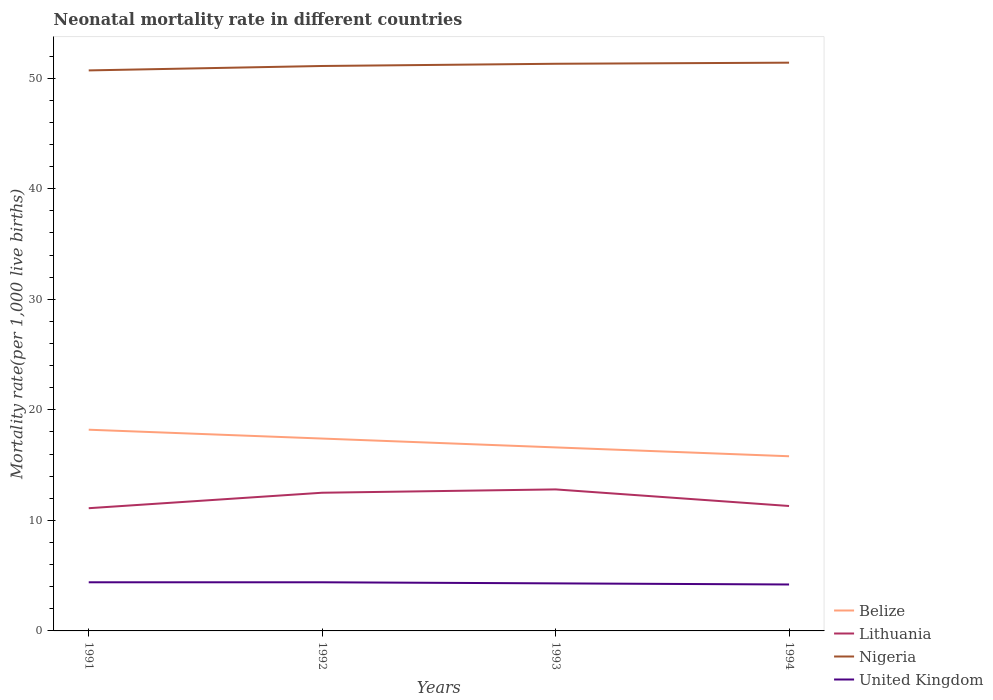How many different coloured lines are there?
Make the answer very short. 4. Across all years, what is the maximum neonatal mortality rate in Belize?
Provide a succinct answer. 15.8. What is the total neonatal mortality rate in United Kingdom in the graph?
Make the answer very short. 0.1. What is the difference between the highest and the second highest neonatal mortality rate in Nigeria?
Offer a very short reply. 0.7. Is the neonatal mortality rate in Nigeria strictly greater than the neonatal mortality rate in United Kingdom over the years?
Offer a terse response. No. How many years are there in the graph?
Offer a terse response. 4. Are the values on the major ticks of Y-axis written in scientific E-notation?
Your answer should be compact. No. Does the graph contain grids?
Make the answer very short. No. Where does the legend appear in the graph?
Your answer should be compact. Bottom right. What is the title of the graph?
Offer a terse response. Neonatal mortality rate in different countries. What is the label or title of the Y-axis?
Offer a very short reply. Mortality rate(per 1,0 live births). What is the Mortality rate(per 1,000 live births) of Belize in 1991?
Offer a terse response. 18.2. What is the Mortality rate(per 1,000 live births) of Lithuania in 1991?
Ensure brevity in your answer.  11.1. What is the Mortality rate(per 1,000 live births) in Nigeria in 1991?
Your answer should be compact. 50.7. What is the Mortality rate(per 1,000 live births) of Belize in 1992?
Provide a succinct answer. 17.4. What is the Mortality rate(per 1,000 live births) in Lithuania in 1992?
Provide a succinct answer. 12.5. What is the Mortality rate(per 1,000 live births) in Nigeria in 1992?
Keep it short and to the point. 51.1. What is the Mortality rate(per 1,000 live births) in Belize in 1993?
Offer a terse response. 16.6. What is the Mortality rate(per 1,000 live births) of Lithuania in 1993?
Ensure brevity in your answer.  12.8. What is the Mortality rate(per 1,000 live births) of Nigeria in 1993?
Give a very brief answer. 51.3. What is the Mortality rate(per 1,000 live births) of United Kingdom in 1993?
Offer a very short reply. 4.3. What is the Mortality rate(per 1,000 live births) of Lithuania in 1994?
Keep it short and to the point. 11.3. What is the Mortality rate(per 1,000 live births) in Nigeria in 1994?
Provide a short and direct response. 51.4. What is the Mortality rate(per 1,000 live births) in United Kingdom in 1994?
Ensure brevity in your answer.  4.2. Across all years, what is the maximum Mortality rate(per 1,000 live births) in Nigeria?
Ensure brevity in your answer.  51.4. Across all years, what is the maximum Mortality rate(per 1,000 live births) of United Kingdom?
Make the answer very short. 4.4. Across all years, what is the minimum Mortality rate(per 1,000 live births) of Belize?
Keep it short and to the point. 15.8. Across all years, what is the minimum Mortality rate(per 1,000 live births) in Lithuania?
Keep it short and to the point. 11.1. Across all years, what is the minimum Mortality rate(per 1,000 live births) in Nigeria?
Your answer should be compact. 50.7. What is the total Mortality rate(per 1,000 live births) in Belize in the graph?
Offer a terse response. 68. What is the total Mortality rate(per 1,000 live births) of Lithuania in the graph?
Offer a very short reply. 47.7. What is the total Mortality rate(per 1,000 live births) in Nigeria in the graph?
Offer a terse response. 204.5. What is the total Mortality rate(per 1,000 live births) of United Kingdom in the graph?
Make the answer very short. 17.3. What is the difference between the Mortality rate(per 1,000 live births) in Lithuania in 1991 and that in 1992?
Make the answer very short. -1.4. What is the difference between the Mortality rate(per 1,000 live births) in Belize in 1991 and that in 1993?
Provide a succinct answer. 1.6. What is the difference between the Mortality rate(per 1,000 live births) of Lithuania in 1991 and that in 1993?
Ensure brevity in your answer.  -1.7. What is the difference between the Mortality rate(per 1,000 live births) of Nigeria in 1991 and that in 1993?
Provide a short and direct response. -0.6. What is the difference between the Mortality rate(per 1,000 live births) of Belize in 1991 and that in 1994?
Your response must be concise. 2.4. What is the difference between the Mortality rate(per 1,000 live births) in Lithuania in 1991 and that in 1994?
Offer a terse response. -0.2. What is the difference between the Mortality rate(per 1,000 live births) of Nigeria in 1991 and that in 1994?
Your answer should be very brief. -0.7. What is the difference between the Mortality rate(per 1,000 live births) of Nigeria in 1992 and that in 1993?
Your answer should be compact. -0.2. What is the difference between the Mortality rate(per 1,000 live births) in Lithuania in 1992 and that in 1994?
Offer a very short reply. 1.2. What is the difference between the Mortality rate(per 1,000 live births) of United Kingdom in 1992 and that in 1994?
Your answer should be compact. 0.2. What is the difference between the Mortality rate(per 1,000 live births) of Nigeria in 1993 and that in 1994?
Offer a very short reply. -0.1. What is the difference between the Mortality rate(per 1,000 live births) of Belize in 1991 and the Mortality rate(per 1,000 live births) of Lithuania in 1992?
Your response must be concise. 5.7. What is the difference between the Mortality rate(per 1,000 live births) in Belize in 1991 and the Mortality rate(per 1,000 live births) in Nigeria in 1992?
Offer a terse response. -32.9. What is the difference between the Mortality rate(per 1,000 live births) of Belize in 1991 and the Mortality rate(per 1,000 live births) of United Kingdom in 1992?
Offer a terse response. 13.8. What is the difference between the Mortality rate(per 1,000 live births) of Lithuania in 1991 and the Mortality rate(per 1,000 live births) of Nigeria in 1992?
Give a very brief answer. -40. What is the difference between the Mortality rate(per 1,000 live births) in Nigeria in 1991 and the Mortality rate(per 1,000 live births) in United Kingdom in 1992?
Offer a terse response. 46.3. What is the difference between the Mortality rate(per 1,000 live births) in Belize in 1991 and the Mortality rate(per 1,000 live births) in Nigeria in 1993?
Provide a succinct answer. -33.1. What is the difference between the Mortality rate(per 1,000 live births) in Lithuania in 1991 and the Mortality rate(per 1,000 live births) in Nigeria in 1993?
Provide a succinct answer. -40.2. What is the difference between the Mortality rate(per 1,000 live births) in Nigeria in 1991 and the Mortality rate(per 1,000 live births) in United Kingdom in 1993?
Give a very brief answer. 46.4. What is the difference between the Mortality rate(per 1,000 live births) in Belize in 1991 and the Mortality rate(per 1,000 live births) in Nigeria in 1994?
Offer a very short reply. -33.2. What is the difference between the Mortality rate(per 1,000 live births) in Belize in 1991 and the Mortality rate(per 1,000 live births) in United Kingdom in 1994?
Offer a terse response. 14. What is the difference between the Mortality rate(per 1,000 live births) of Lithuania in 1991 and the Mortality rate(per 1,000 live births) of Nigeria in 1994?
Offer a terse response. -40.3. What is the difference between the Mortality rate(per 1,000 live births) of Nigeria in 1991 and the Mortality rate(per 1,000 live births) of United Kingdom in 1994?
Offer a terse response. 46.5. What is the difference between the Mortality rate(per 1,000 live births) of Belize in 1992 and the Mortality rate(per 1,000 live births) of Nigeria in 1993?
Offer a terse response. -33.9. What is the difference between the Mortality rate(per 1,000 live births) in Belize in 1992 and the Mortality rate(per 1,000 live births) in United Kingdom in 1993?
Offer a terse response. 13.1. What is the difference between the Mortality rate(per 1,000 live births) of Lithuania in 1992 and the Mortality rate(per 1,000 live births) of Nigeria in 1993?
Your response must be concise. -38.8. What is the difference between the Mortality rate(per 1,000 live births) in Lithuania in 1992 and the Mortality rate(per 1,000 live births) in United Kingdom in 1993?
Your response must be concise. 8.2. What is the difference between the Mortality rate(per 1,000 live births) of Nigeria in 1992 and the Mortality rate(per 1,000 live births) of United Kingdom in 1993?
Offer a very short reply. 46.8. What is the difference between the Mortality rate(per 1,000 live births) in Belize in 1992 and the Mortality rate(per 1,000 live births) in Lithuania in 1994?
Keep it short and to the point. 6.1. What is the difference between the Mortality rate(per 1,000 live births) of Belize in 1992 and the Mortality rate(per 1,000 live births) of Nigeria in 1994?
Your response must be concise. -34. What is the difference between the Mortality rate(per 1,000 live births) of Lithuania in 1992 and the Mortality rate(per 1,000 live births) of Nigeria in 1994?
Your answer should be compact. -38.9. What is the difference between the Mortality rate(per 1,000 live births) in Nigeria in 1992 and the Mortality rate(per 1,000 live births) in United Kingdom in 1994?
Provide a succinct answer. 46.9. What is the difference between the Mortality rate(per 1,000 live births) of Belize in 1993 and the Mortality rate(per 1,000 live births) of Nigeria in 1994?
Offer a very short reply. -34.8. What is the difference between the Mortality rate(per 1,000 live births) in Belize in 1993 and the Mortality rate(per 1,000 live births) in United Kingdom in 1994?
Provide a short and direct response. 12.4. What is the difference between the Mortality rate(per 1,000 live births) of Lithuania in 1993 and the Mortality rate(per 1,000 live births) of Nigeria in 1994?
Provide a succinct answer. -38.6. What is the difference between the Mortality rate(per 1,000 live births) of Nigeria in 1993 and the Mortality rate(per 1,000 live births) of United Kingdom in 1994?
Ensure brevity in your answer.  47.1. What is the average Mortality rate(per 1,000 live births) in Belize per year?
Provide a succinct answer. 17. What is the average Mortality rate(per 1,000 live births) of Lithuania per year?
Your answer should be very brief. 11.93. What is the average Mortality rate(per 1,000 live births) of Nigeria per year?
Keep it short and to the point. 51.12. What is the average Mortality rate(per 1,000 live births) in United Kingdom per year?
Offer a terse response. 4.33. In the year 1991, what is the difference between the Mortality rate(per 1,000 live births) of Belize and Mortality rate(per 1,000 live births) of Nigeria?
Your answer should be compact. -32.5. In the year 1991, what is the difference between the Mortality rate(per 1,000 live births) of Belize and Mortality rate(per 1,000 live births) of United Kingdom?
Provide a succinct answer. 13.8. In the year 1991, what is the difference between the Mortality rate(per 1,000 live births) of Lithuania and Mortality rate(per 1,000 live births) of Nigeria?
Offer a very short reply. -39.6. In the year 1991, what is the difference between the Mortality rate(per 1,000 live births) of Nigeria and Mortality rate(per 1,000 live births) of United Kingdom?
Give a very brief answer. 46.3. In the year 1992, what is the difference between the Mortality rate(per 1,000 live births) of Belize and Mortality rate(per 1,000 live births) of Lithuania?
Your answer should be very brief. 4.9. In the year 1992, what is the difference between the Mortality rate(per 1,000 live births) of Belize and Mortality rate(per 1,000 live births) of Nigeria?
Your response must be concise. -33.7. In the year 1992, what is the difference between the Mortality rate(per 1,000 live births) in Lithuania and Mortality rate(per 1,000 live births) in Nigeria?
Your answer should be compact. -38.6. In the year 1992, what is the difference between the Mortality rate(per 1,000 live births) of Lithuania and Mortality rate(per 1,000 live births) of United Kingdom?
Your response must be concise. 8.1. In the year 1992, what is the difference between the Mortality rate(per 1,000 live births) in Nigeria and Mortality rate(per 1,000 live births) in United Kingdom?
Make the answer very short. 46.7. In the year 1993, what is the difference between the Mortality rate(per 1,000 live births) in Belize and Mortality rate(per 1,000 live births) in Nigeria?
Keep it short and to the point. -34.7. In the year 1993, what is the difference between the Mortality rate(per 1,000 live births) of Lithuania and Mortality rate(per 1,000 live births) of Nigeria?
Ensure brevity in your answer.  -38.5. In the year 1993, what is the difference between the Mortality rate(per 1,000 live births) in Lithuania and Mortality rate(per 1,000 live births) in United Kingdom?
Give a very brief answer. 8.5. In the year 1993, what is the difference between the Mortality rate(per 1,000 live births) in Nigeria and Mortality rate(per 1,000 live births) in United Kingdom?
Your response must be concise. 47. In the year 1994, what is the difference between the Mortality rate(per 1,000 live births) in Belize and Mortality rate(per 1,000 live births) in Lithuania?
Make the answer very short. 4.5. In the year 1994, what is the difference between the Mortality rate(per 1,000 live births) of Belize and Mortality rate(per 1,000 live births) of Nigeria?
Your answer should be compact. -35.6. In the year 1994, what is the difference between the Mortality rate(per 1,000 live births) of Belize and Mortality rate(per 1,000 live births) of United Kingdom?
Your response must be concise. 11.6. In the year 1994, what is the difference between the Mortality rate(per 1,000 live births) in Lithuania and Mortality rate(per 1,000 live births) in Nigeria?
Provide a succinct answer. -40.1. In the year 1994, what is the difference between the Mortality rate(per 1,000 live births) in Lithuania and Mortality rate(per 1,000 live births) in United Kingdom?
Your answer should be very brief. 7.1. In the year 1994, what is the difference between the Mortality rate(per 1,000 live births) in Nigeria and Mortality rate(per 1,000 live births) in United Kingdom?
Give a very brief answer. 47.2. What is the ratio of the Mortality rate(per 1,000 live births) in Belize in 1991 to that in 1992?
Offer a terse response. 1.05. What is the ratio of the Mortality rate(per 1,000 live births) in Lithuania in 1991 to that in 1992?
Make the answer very short. 0.89. What is the ratio of the Mortality rate(per 1,000 live births) in Nigeria in 1991 to that in 1992?
Make the answer very short. 0.99. What is the ratio of the Mortality rate(per 1,000 live births) of United Kingdom in 1991 to that in 1992?
Your response must be concise. 1. What is the ratio of the Mortality rate(per 1,000 live births) of Belize in 1991 to that in 1993?
Provide a succinct answer. 1.1. What is the ratio of the Mortality rate(per 1,000 live births) of Lithuania in 1991 to that in 1993?
Your answer should be compact. 0.87. What is the ratio of the Mortality rate(per 1,000 live births) in Nigeria in 1991 to that in 1993?
Offer a very short reply. 0.99. What is the ratio of the Mortality rate(per 1,000 live births) in United Kingdom in 1991 to that in 1993?
Offer a terse response. 1.02. What is the ratio of the Mortality rate(per 1,000 live births) of Belize in 1991 to that in 1994?
Your response must be concise. 1.15. What is the ratio of the Mortality rate(per 1,000 live births) of Lithuania in 1991 to that in 1994?
Ensure brevity in your answer.  0.98. What is the ratio of the Mortality rate(per 1,000 live births) of Nigeria in 1991 to that in 1994?
Give a very brief answer. 0.99. What is the ratio of the Mortality rate(per 1,000 live births) of United Kingdom in 1991 to that in 1994?
Offer a terse response. 1.05. What is the ratio of the Mortality rate(per 1,000 live births) in Belize in 1992 to that in 1993?
Give a very brief answer. 1.05. What is the ratio of the Mortality rate(per 1,000 live births) in Lithuania in 1992 to that in 1993?
Give a very brief answer. 0.98. What is the ratio of the Mortality rate(per 1,000 live births) in Nigeria in 1992 to that in 1993?
Your response must be concise. 1. What is the ratio of the Mortality rate(per 1,000 live births) of United Kingdom in 1992 to that in 1993?
Ensure brevity in your answer.  1.02. What is the ratio of the Mortality rate(per 1,000 live births) of Belize in 1992 to that in 1994?
Provide a short and direct response. 1.1. What is the ratio of the Mortality rate(per 1,000 live births) in Lithuania in 1992 to that in 1994?
Offer a very short reply. 1.11. What is the ratio of the Mortality rate(per 1,000 live births) in Nigeria in 1992 to that in 1994?
Your answer should be very brief. 0.99. What is the ratio of the Mortality rate(per 1,000 live births) in United Kingdom in 1992 to that in 1994?
Offer a terse response. 1.05. What is the ratio of the Mortality rate(per 1,000 live births) of Belize in 1993 to that in 1994?
Ensure brevity in your answer.  1.05. What is the ratio of the Mortality rate(per 1,000 live births) of Lithuania in 1993 to that in 1994?
Offer a very short reply. 1.13. What is the ratio of the Mortality rate(per 1,000 live births) of United Kingdom in 1993 to that in 1994?
Your answer should be very brief. 1.02. What is the difference between the highest and the second highest Mortality rate(per 1,000 live births) of Lithuania?
Your answer should be compact. 0.3. What is the difference between the highest and the second highest Mortality rate(per 1,000 live births) of Nigeria?
Your answer should be compact. 0.1. What is the difference between the highest and the lowest Mortality rate(per 1,000 live births) of Nigeria?
Provide a short and direct response. 0.7. 